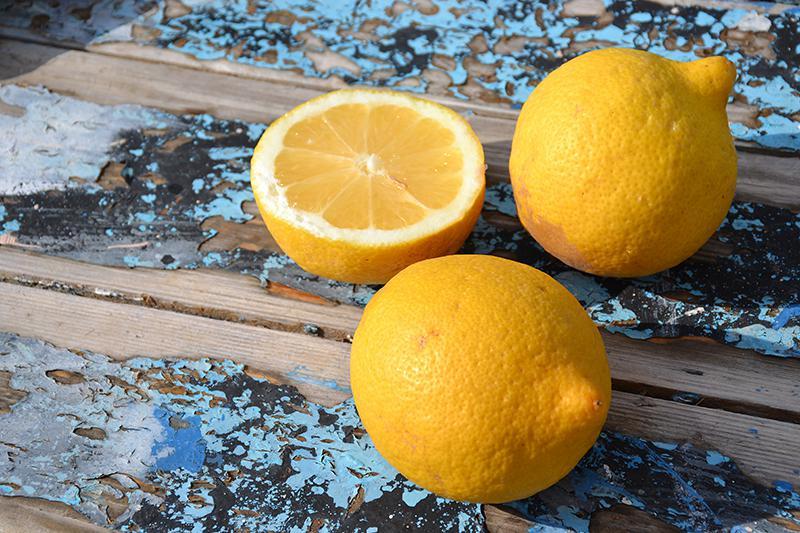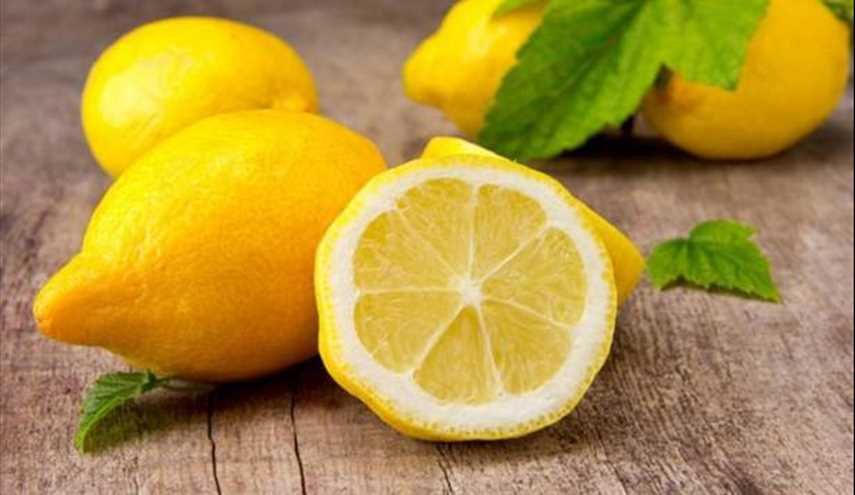The first image is the image on the left, the second image is the image on the right. Considering the images on both sides, is "A single half of a lemon sits with some whole lemons in each of the images." valid? Answer yes or no. Yes. The first image is the image on the left, the second image is the image on the right. For the images shown, is this caption "The lemons are still hanging from the tree in one picture." true? Answer yes or no. No. 